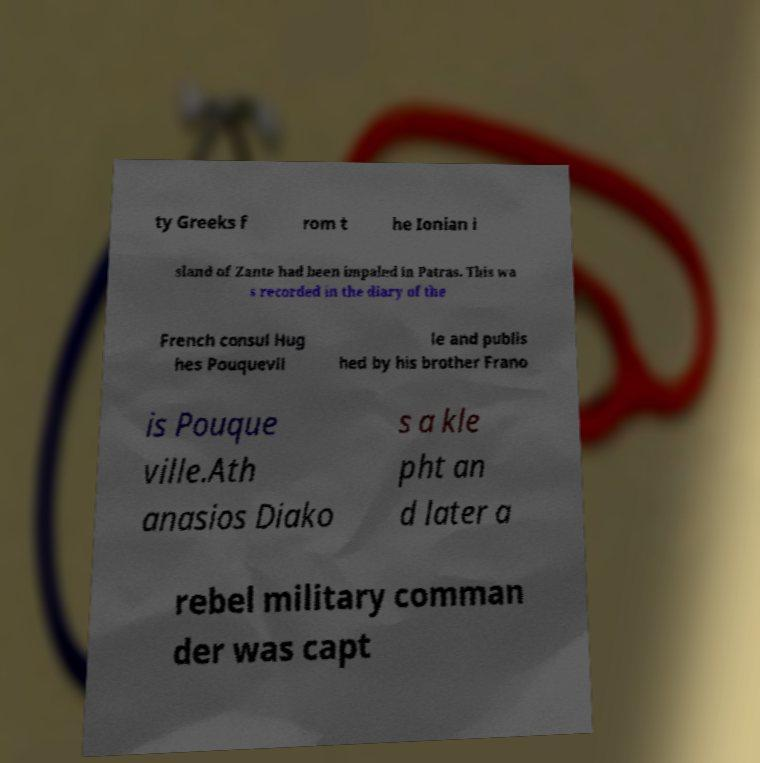Can you accurately transcribe the text from the provided image for me? ty Greeks f rom t he Ionian i sland of Zante had been impaled in Patras. This wa s recorded in the diary of the French consul Hug hes Pouquevil le and publis hed by his brother Frano is Pouque ville.Ath anasios Diako s a kle pht an d later a rebel military comman der was capt 